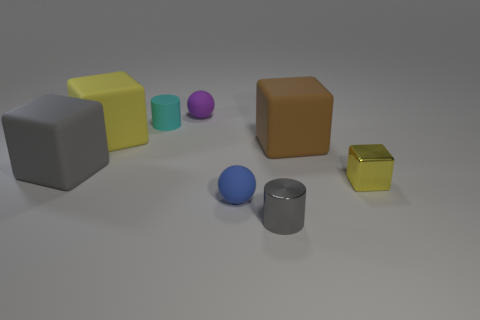Subtract all large gray rubber cubes. How many cubes are left? 3 Subtract all blue cylinders. How many yellow cubes are left? 2 Subtract all brown cubes. How many cubes are left? 3 Subtract all purple cubes. Subtract all green spheres. How many cubes are left? 4 Add 1 tiny purple rubber spheres. How many objects exist? 9 Subtract all cylinders. How many objects are left? 6 Add 8 big purple metal balls. How many big purple metal balls exist? 8 Subtract 1 brown blocks. How many objects are left? 7 Subtract all small purple balls. Subtract all brown things. How many objects are left? 6 Add 5 tiny yellow metal cubes. How many tiny yellow metal cubes are left? 6 